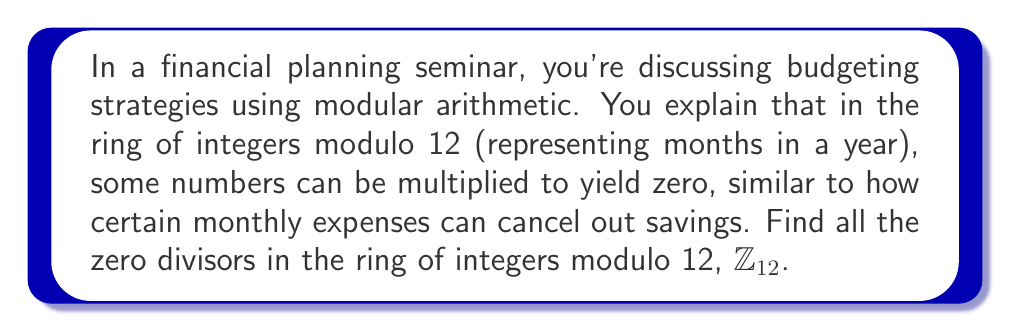Teach me how to tackle this problem. To find the zero divisors in $\mathbb{Z}_{12}$, we need to identify all non-zero elements $a$ in $\mathbb{Z}_{12}$ for which there exists a non-zero element $b$ such that $ab \equiv 0 \pmod{12}$.

Let's systematically check each non-zero element of $\mathbb{Z}_{12}$:

1) For $a = 1$: No non-zero $b$ exists such that $1b \equiv 0 \pmod{12}$. 1 is not a zero divisor.

2) For $a = 2$:
   $2 \cdot 6 \equiv 0 \pmod{12}$, so 2 is a zero divisor.

3) For $a = 3$:
   $3 \cdot 4 \equiv 0 \pmod{12}$, so 3 is a zero divisor.

4) For $a = 4$:
   $4 \cdot 3 \equiv 0 \pmod{12}$, so 4 is a zero divisor.

5) For $a = 5$: No non-zero $b$ exists such that $5b \equiv 0 \pmod{12}$. 5 is not a zero divisor.

6) For $a = 6$:
   $6 \cdot 2 \equiv 0 \pmod{12}$, so 6 is a zero divisor.

7) For $a = 7$: No non-zero $b$ exists such that $7b \equiv 0 \pmod{12}$. 7 is not a zero divisor.

8) For $a = 8$:
   $8 \cdot 3 \equiv 0 \pmod{12}$, so 8 is a zero divisor.

9) For $a = 9$:
   $9 \cdot 4 \equiv 0 \pmod{12}$, so 9 is a zero divisor.

10) For $a = 10$:
    $10 \cdot 6 \equiv 0 \pmod{12}$, so 10 is a zero divisor.

11) For $a = 11$: No non-zero $b$ exists such that $11b \equiv 0 \pmod{12}$. 11 is not a zero divisor.

Therefore, the zero divisors in $\mathbb{Z}_{12}$ are 2, 3, 4, 6, 8, 9, and 10.
Answer: The zero divisors in $\mathbb{Z}_{12}$ are $\{2, 3, 4, 6, 8, 9, 10\}$. 